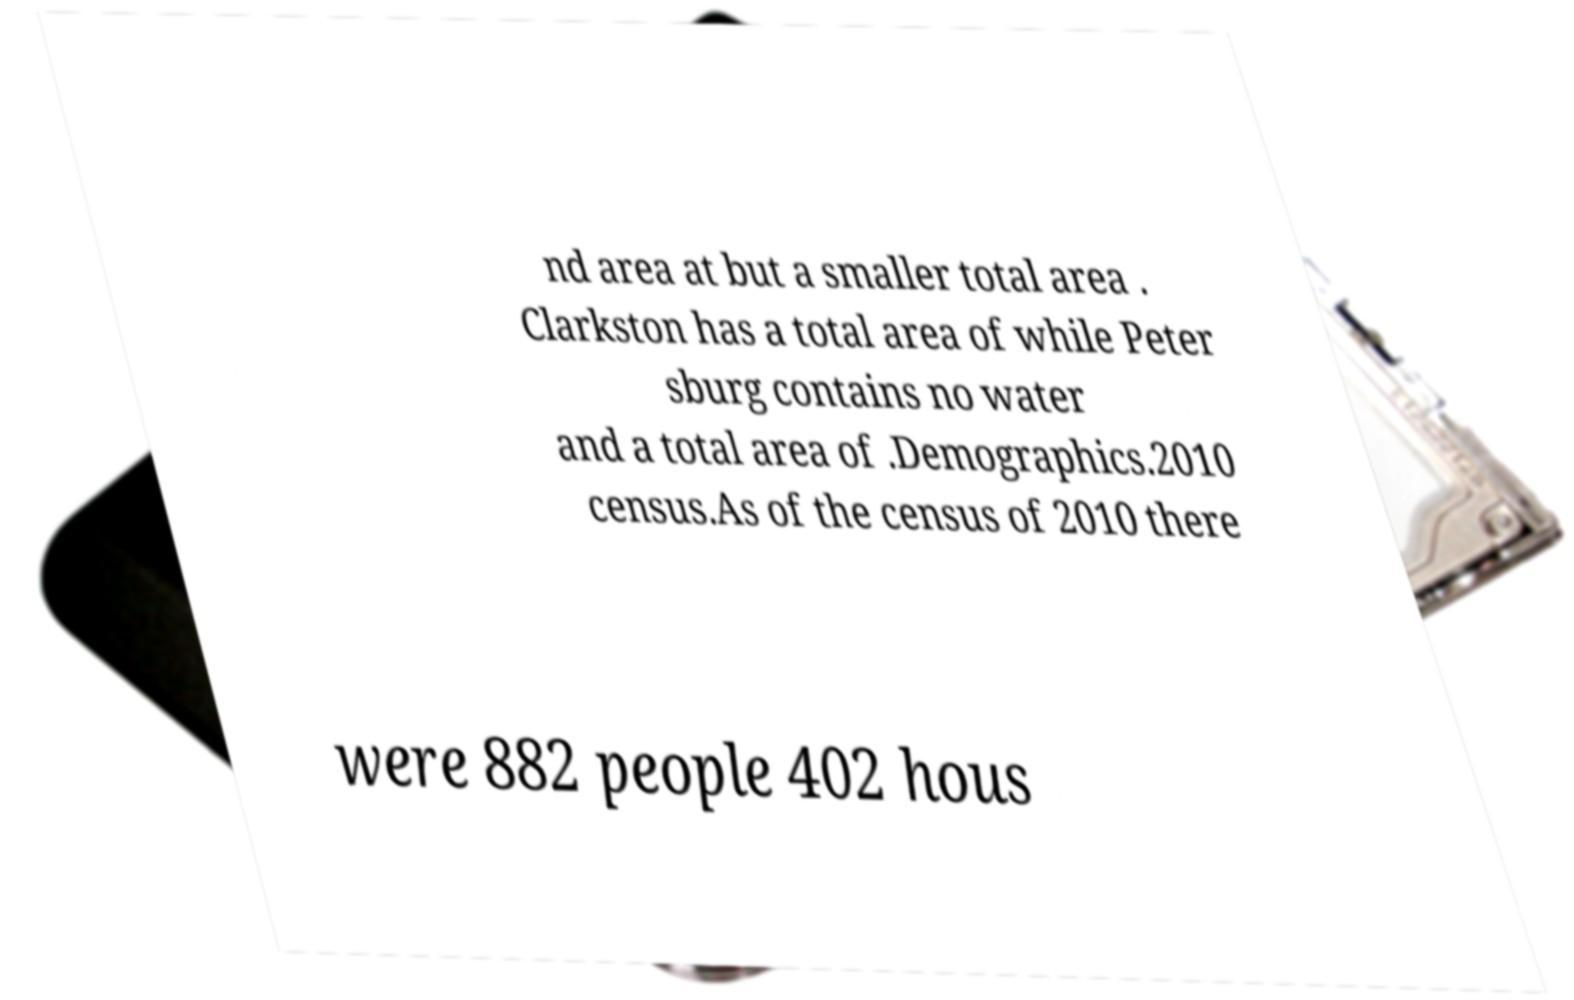For documentation purposes, I need the text within this image transcribed. Could you provide that? nd area at but a smaller total area . Clarkston has a total area of while Peter sburg contains no water and a total area of .Demographics.2010 census.As of the census of 2010 there were 882 people 402 hous 